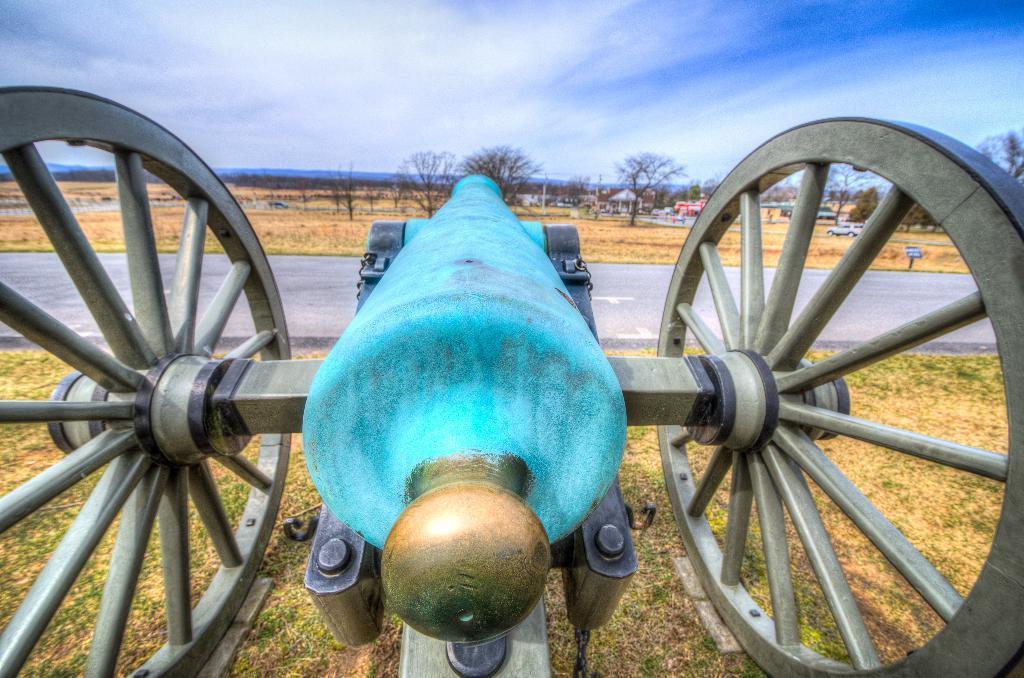Describe this image in one or two sentences. In this picture we can see a canon on the grass. There is a road. We can see a few plants, vehicles and houses in the background. Sky is blue in color and cloudy. 